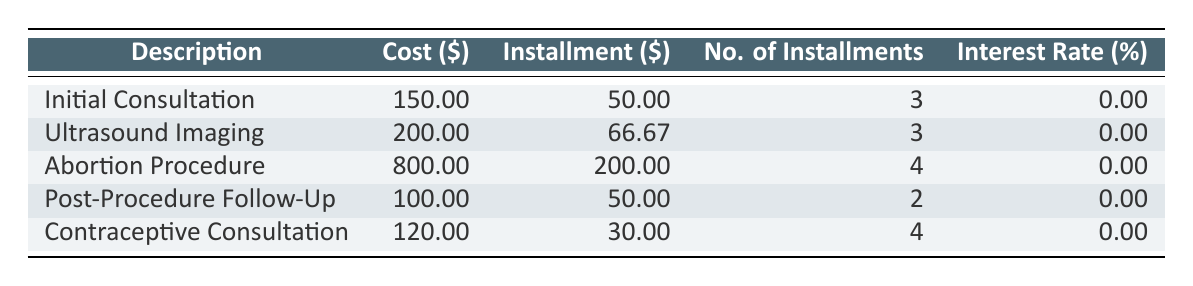What is the total cost of the Abortion Procedure? The table lists the cost for the Abortion Procedure as \$800.00.
Answer: 800.00 How many installments are required for the Post-Procedure Follow-Up? According to the table, the Post-Procedure Follow-Up requires 2 installments.
Answer: 2 What is the total of the installment amounts for the Ultrasound Imaging? The Ultrasound Imaging has an installment amount of \$66.67 and a total of 3 installments, so the total is 66.67 * 3 = 200.01, which matches the cost in the table.
Answer: 200.01 Is the interest rate for the Contraceptive Consultation zero? The table shows the interest rate for the Contraceptive Consultation is 0.00%, confirming it is indeed zero.
Answer: Yes What is the average number of installments for all listed medical expenses? To calculate the average, sum the number of installments: 3 (Initial Consultation) + 3 (Ultrasound Imaging) + 4 (Abortion Procedure) + 2 (Post-Procedure Follow-Up) + 4 (Contraceptive Consultation) = 16. There are 5 expenses, so the average is 16 / 5 = 3.2.
Answer: 3.2 How much would someone pay in total for the Initial Consultation and the Post-Procedure Follow-Up? The cost for the Initial Consultation is \$150.00 and the Post-Procedure Follow-Up is \$100.00. Adding these two gives 150.00 + 100.00 = 250.00.
Answer: 250.00 Which medical expense has the highest installment payment amount? The table shows the Abortion Procedure has the highest installment amount at \$200.00, compared to others.
Answer: Abortion Procedure Is there any medical expense with an installment amount less than \$30.00? None of the expenses listed have an installment amount lower than \$30.00; they start at \$30.00 for Contraceptive Consultation.
Answer: No What is the total cost for the three procedures: Abortion Procedure, Post-Procedure Follow-Up, and Contraceptive Consultation? The costs for these procedures are \$800.00 (Abortion) + \$100.00 (Post-Procedure Follow-Up) + \$120.00 (Contraceptive Consultation) = 800 + 100 + 120 = 1020.
Answer: 1020 